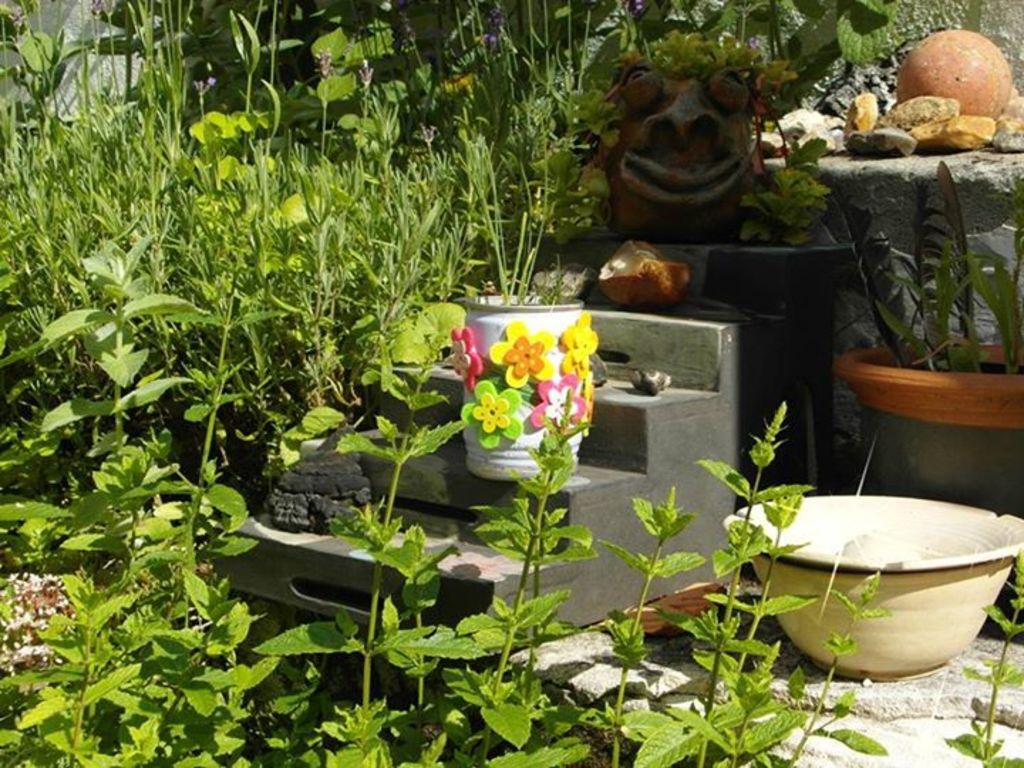What type of living organisms can be seen in the image? Plants can be seen in the image. What are the plants contained in? There are pots in the image that contain the plants. Can you describe the colorful pot in the image? There is a colorful pot on the stairs in the image. What other objects are visible in the image? There are objects in the image, including pebbles. What type of quilt is draped over the plants in the image? There is no quilt present in the image; it features plants in pots and a colorful pot on the stairs. 